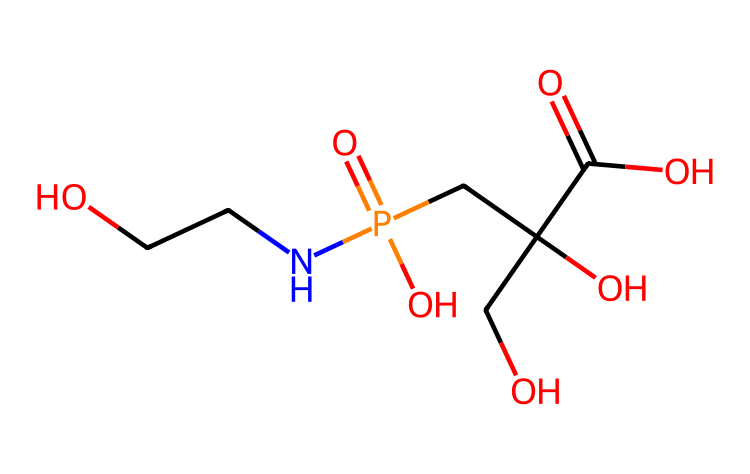what is the name of this chemical? The chemical represented by the SMILES is glyphosate, which is a well-known herbicide.
Answer: glyphosate how many nitrogen atoms are in this chemical? By examining the structure, we can identify one nitrogen atom (N) present in the compound.
Answer: one how many phosphorus atoms are in this chemical? There is one phosphorus atom (P) discernible in the chemical structure as indicated in the SMILES.
Answer: one which functional group is present in glyphosate that contributes to its herbicidal activity? The presence of the carboxylic acid functional group (-COOH) is crucial as it plays a significant role in glyphosate's herbicidal action.
Answer: carboxylic acid what is the overall charge of the phosphate group in glyphosate? In glyphosate, the phosphate group typically carries a -1 charge due to the presence of three oxygen atoms and the phosphorous atom having one coordinate bond and two negative charges.
Answer: minus one how many carbon atoms can be found in this chemical? Counting the carbon atoms (C) in the structure results in a total of five carbon atoms.
Answer: five what kind of compound does glyphosate belong to due to the presence of phosphorus? Glyphosate is categorized as a phosphorus compound due to the inclusion of a phosphorus atom in its molecular structure.
Answer: phosphorus compound 